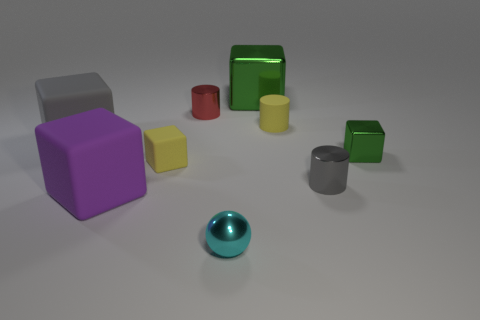Are all the objects made of the same material? The objects appear to have different finishes—some have a matte look while others are shiny, which suggests they could be made of different materials or treated differently to create varied textures. 